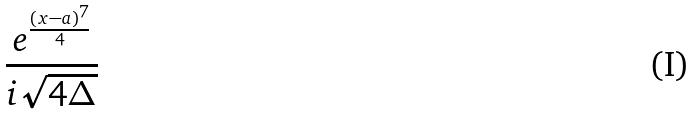<formula> <loc_0><loc_0><loc_500><loc_500>\frac { e ^ { \frac { ( x - a ) ^ { 7 } } { 4 } } } { i \sqrt { 4 \Delta } }</formula> 